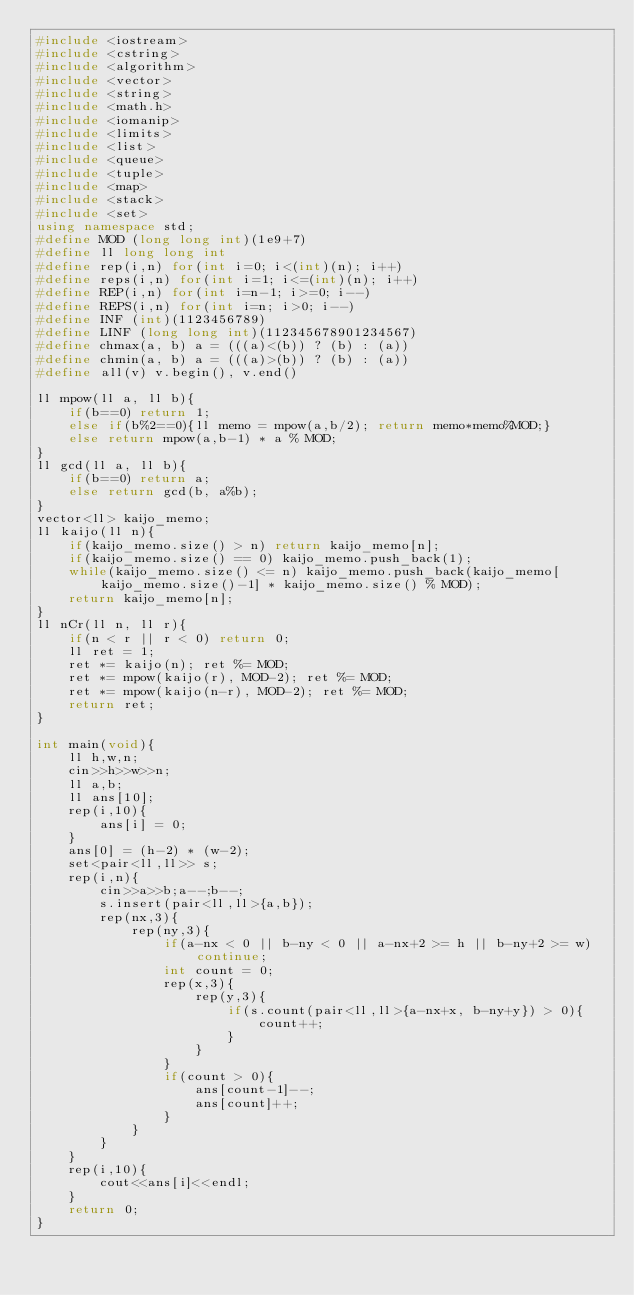<code> <loc_0><loc_0><loc_500><loc_500><_C++_>#include <iostream>
#include <cstring>
#include <algorithm>
#include <vector>
#include <string>
#include <math.h>
#include <iomanip>
#include <limits>
#include <list>
#include <queue>
#include <tuple>
#include <map>
#include <stack>
#include <set>
using namespace std;
#define MOD (long long int)(1e9+7)
#define ll long long int
#define rep(i,n) for(int i=0; i<(int)(n); i++)
#define reps(i,n) for(int i=1; i<=(int)(n); i++)
#define REP(i,n) for(int i=n-1; i>=0; i--)
#define REPS(i,n) for(int i=n; i>0; i--)
#define INF (int)(1123456789)
#define LINF (long long int)(112345678901234567)
#define chmax(a, b) a = (((a)<(b)) ? (b) : (a))
#define chmin(a, b) a = (((a)>(b)) ? (b) : (a))
#define all(v) v.begin(), v.end()

ll mpow(ll a, ll b){
	if(b==0) return 1;
	else if(b%2==0){ll memo = mpow(a,b/2); return memo*memo%MOD;}
	else return mpow(a,b-1) * a % MOD;
}
ll gcd(ll a, ll b){
	if(b==0) return a;
	else return gcd(b, a%b);
}
vector<ll> kaijo_memo;
ll kaijo(ll n){
	if(kaijo_memo.size() > n) return kaijo_memo[n];
	if(kaijo_memo.size() == 0) kaijo_memo.push_back(1);
	while(kaijo_memo.size() <= n) kaijo_memo.push_back(kaijo_memo[kaijo_memo.size()-1] * kaijo_memo.size() % MOD);
	return kaijo_memo[n];
}
ll nCr(ll n, ll r){
	if(n < r || r < 0) return 0;
	ll ret = 1;
	ret *= kaijo(n); ret %= MOD;
	ret *= mpow(kaijo(r), MOD-2); ret %= MOD;
	ret *= mpow(kaijo(n-r), MOD-2); ret %= MOD;
	return ret;
}

int main(void){
	ll h,w,n;
	cin>>h>>w>>n;
	ll a,b;
	ll ans[10];
	rep(i,10){
		ans[i] = 0;
	}
	ans[0] = (h-2) * (w-2);
	set<pair<ll,ll>> s;
	rep(i,n){
		cin>>a>>b;a--;b--;
		s.insert(pair<ll,ll>{a,b});
		rep(nx,3){
			rep(ny,3){
				if(a-nx < 0 || b-ny < 0 || a-nx+2 >= h || b-ny+2 >= w) continue;
				int count = 0;
				rep(x,3){
					rep(y,3){
						if(s.count(pair<ll,ll>{a-nx+x, b-ny+y}) > 0){
							count++;
						}
					}
				}
				if(count > 0){
					ans[count-1]--;
					ans[count]++;
				}
			}
		}
	}
	rep(i,10){
		cout<<ans[i]<<endl;
	}
	return 0;
}
</code> 